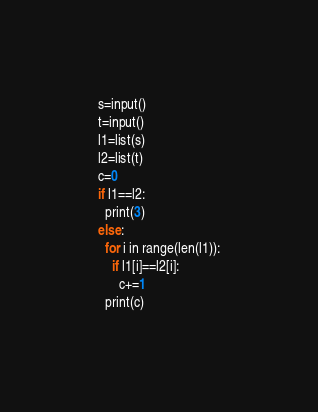<code> <loc_0><loc_0><loc_500><loc_500><_Python_>s=input()
t=input()
l1=list(s)
l2=list(t)
c=0
if l1==l2:
  print(3)
else:
  for i in range(len(l1)):
    if l1[i]==l2[i]:
      c+=1
  print(c) </code> 